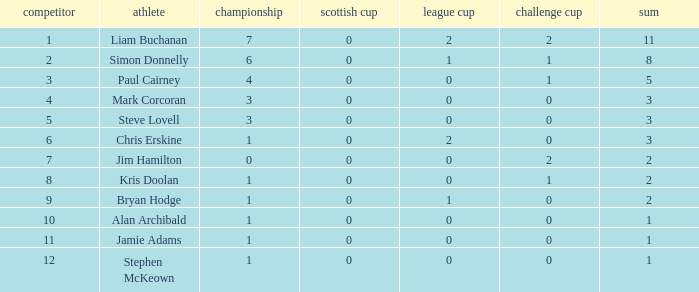What was the lowest number of points scored in the league cup? 0.0. 